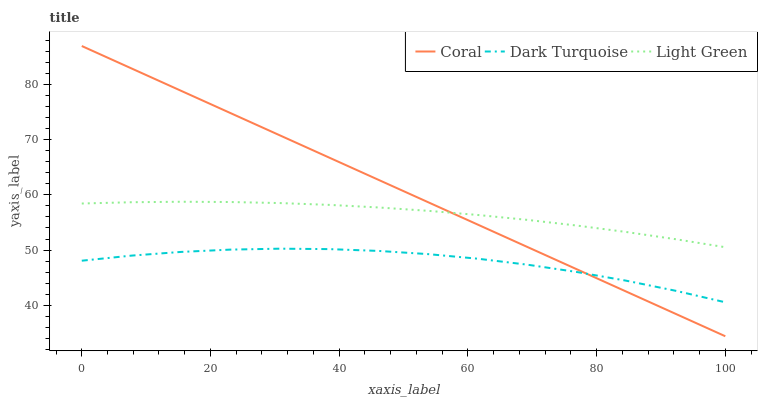Does Dark Turquoise have the minimum area under the curve?
Answer yes or no. Yes. Does Coral have the maximum area under the curve?
Answer yes or no. Yes. Does Light Green have the minimum area under the curve?
Answer yes or no. No. Does Light Green have the maximum area under the curve?
Answer yes or no. No. Is Coral the smoothest?
Answer yes or no. Yes. Is Dark Turquoise the roughest?
Answer yes or no. Yes. Is Light Green the smoothest?
Answer yes or no. No. Is Light Green the roughest?
Answer yes or no. No. Does Light Green have the lowest value?
Answer yes or no. No. Does Coral have the highest value?
Answer yes or no. Yes. Does Light Green have the highest value?
Answer yes or no. No. Is Dark Turquoise less than Light Green?
Answer yes or no. Yes. Is Light Green greater than Dark Turquoise?
Answer yes or no. Yes. Does Coral intersect Dark Turquoise?
Answer yes or no. Yes. Is Coral less than Dark Turquoise?
Answer yes or no. No. Is Coral greater than Dark Turquoise?
Answer yes or no. No. Does Dark Turquoise intersect Light Green?
Answer yes or no. No. 